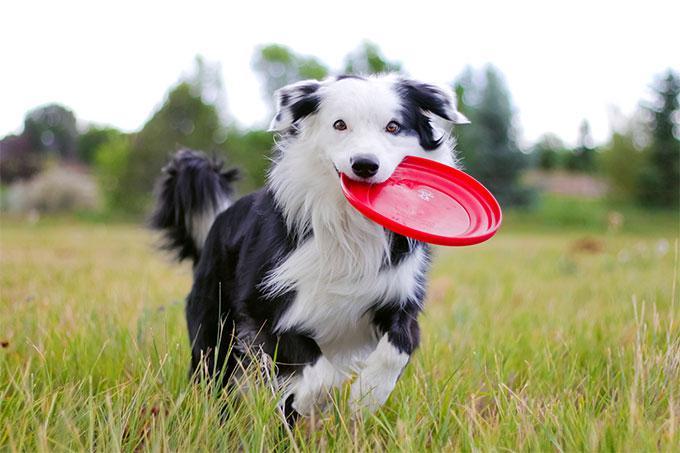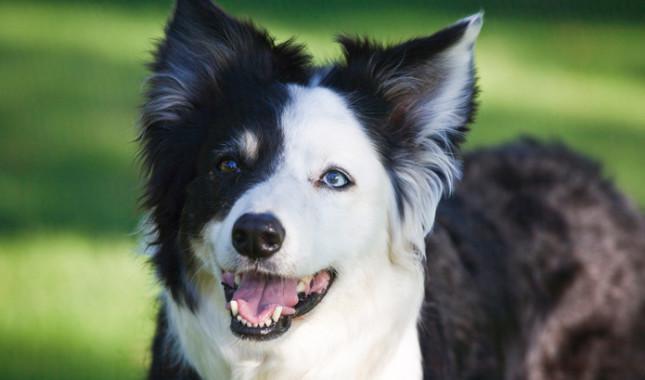The first image is the image on the left, the second image is the image on the right. For the images shown, is this caption "There are two animals" true? Answer yes or no. Yes. The first image is the image on the left, the second image is the image on the right. For the images displayed, is the sentence "One image shows two animals side-by-side with a plain backdrop." factually correct? Answer yes or no. No. 